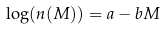Convert formula to latex. <formula><loc_0><loc_0><loc_500><loc_500>\log ( n ( M ) ) = a - b M</formula> 